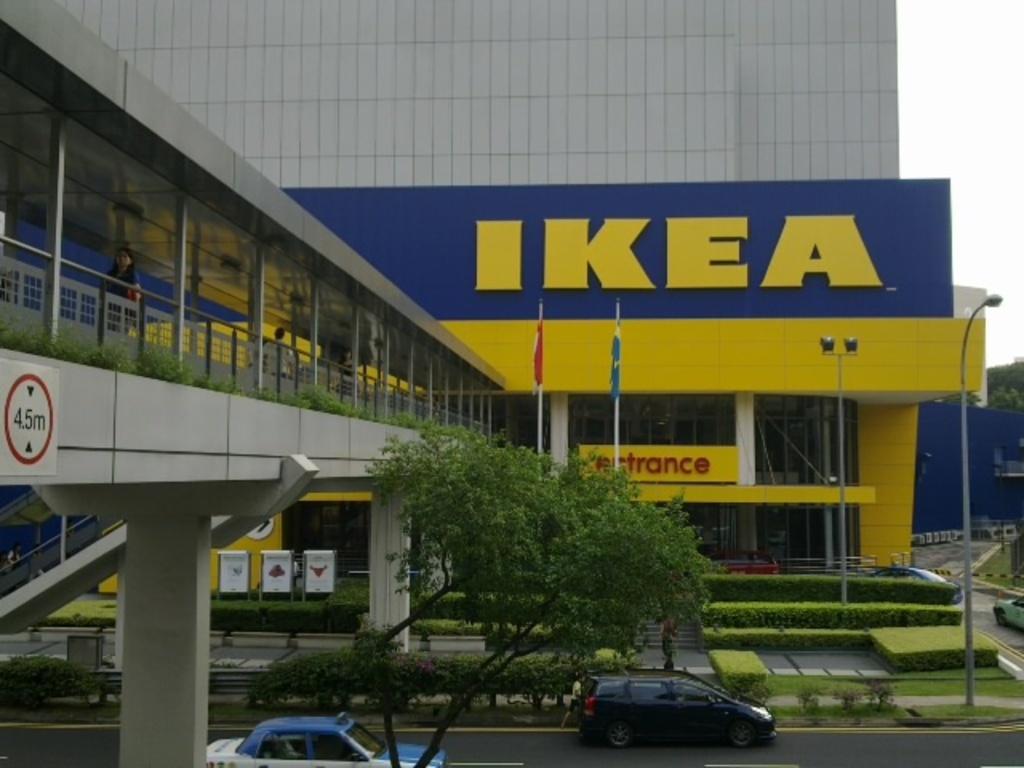In one or two sentences, can you explain what this image depicts? In this picture we can see cars on the road, banners, flags, poles, trees, fence, building and in the background we can see the sky. 